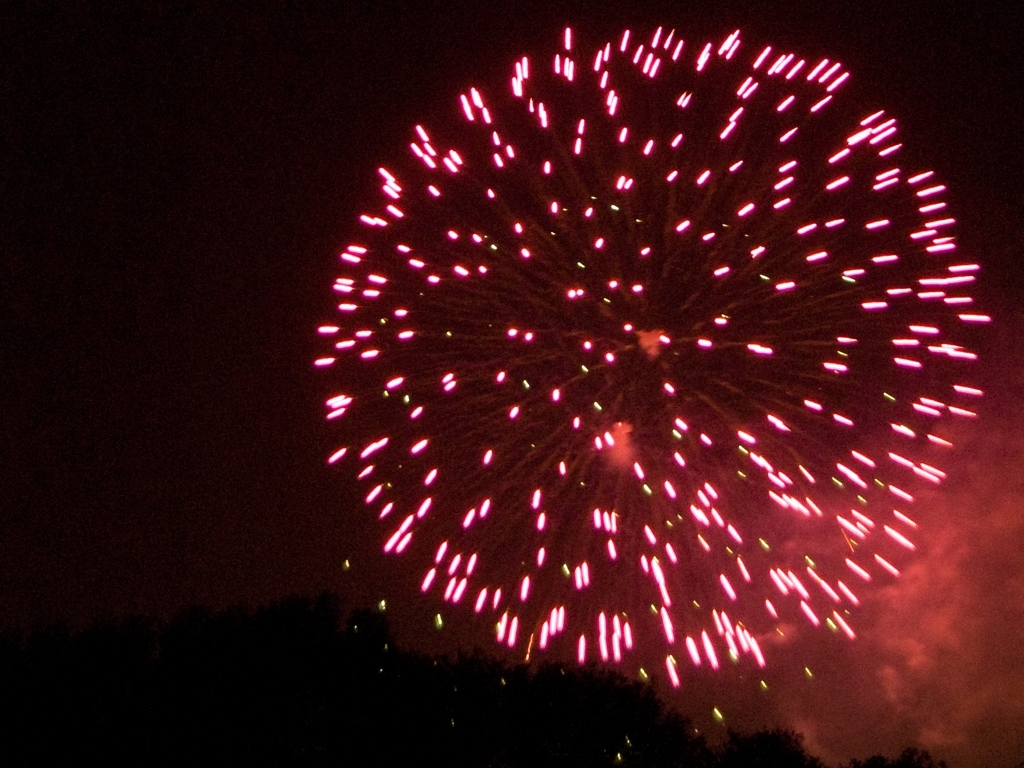What is the quality of this image?
A. Medium
B. High
C. Exceptional
Answer with the option's letter from the given choices directly. The quality of the image can be considered as 'A. Medium' due to several factors. The photograph depicts a fireworks display with a vivid arrangement of pink streaks against a dark sky. While the colors are striking, the image lacks sharpness, and the overall composition is relatively standard without any standout features that might elevate it to a high or exceptional quality rating. There is noticeable noise in the darker areas, suggesting either a high ISO setting or a less sensitive camera sensor was used. Moreover, the fireworks themselves appear slightly blurred, potentially due to a slow shutter speed that was not quick enough to freeze the motion completely. These elements contribute to the medium quality of the image. 